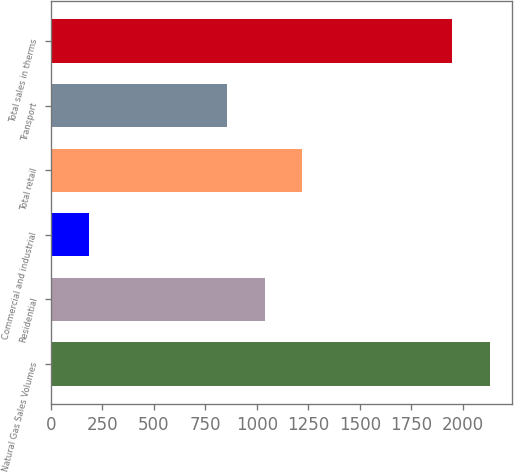<chart> <loc_0><loc_0><loc_500><loc_500><bar_chart><fcel>Natural Gas Sales Volumes<fcel>Residential<fcel>Commercial and industrial<fcel>Total retail<fcel>Transport<fcel>Total sales in therms<nl><fcel>2131.34<fcel>1038.14<fcel>187.6<fcel>1220.98<fcel>855.3<fcel>1948.5<nl></chart> 